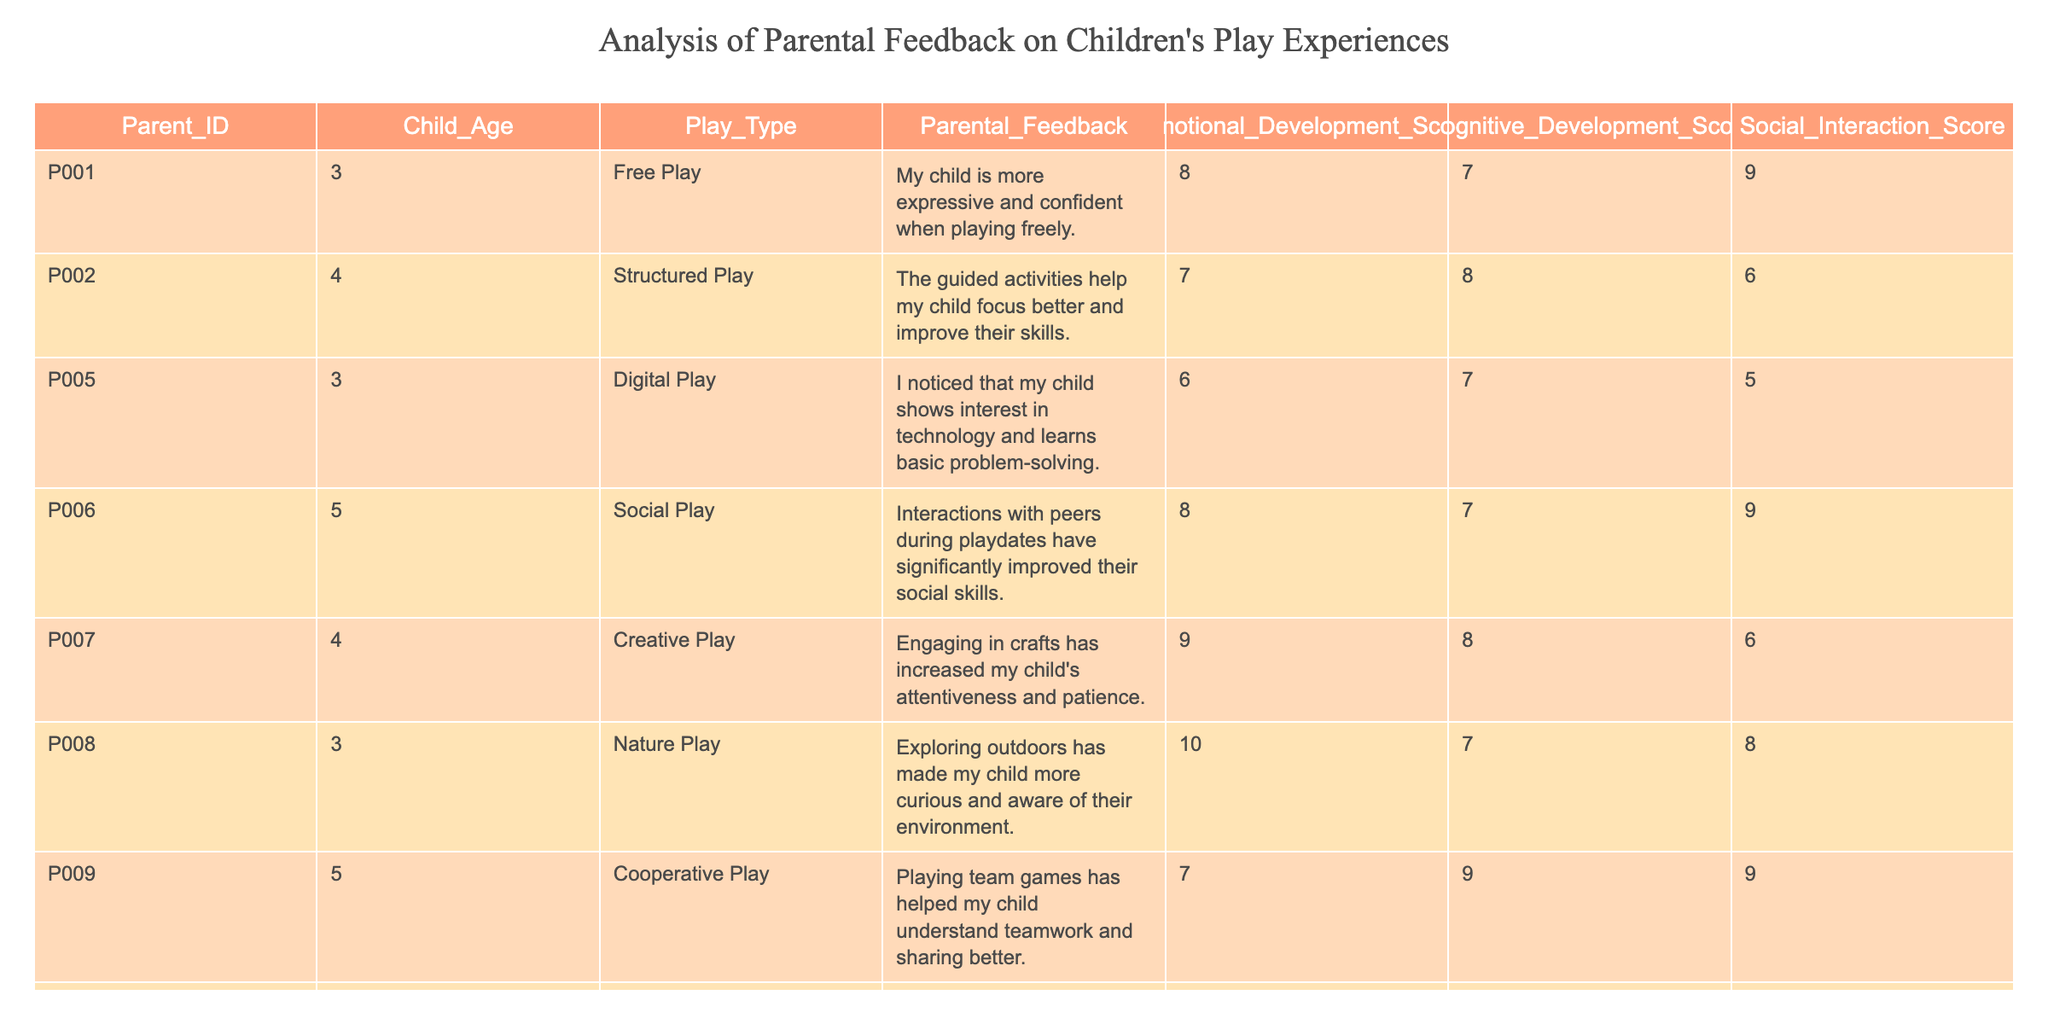What is the emotional development score for the child with parent ID P008? Looking at the table, we find the row with Parent_ID P008, which shows an Emotional Development Score of 10.
Answer: 10 What type of play has the highest cognitive development score? By examining the Cognitive Development Scores, we see that Creative Play (P007) has a score of 8, while the highest score is found with Cooperative Play (P009) at 9.
Answer: Cooperative Play Is it true that solitary play leads to a higher social interaction score than digital play? Looking at the Social Interaction Scores, Solitary Play (P010) has a score of 4, while Digital Play (P005) has a score of 5. Since 4 is not greater than 5, the statement is false.
Answer: No What is the average cognitive development score for children aged 3? The Cognitive Development Scores for children aged 3 are 9 (P001), 7 (P005), and 8 (P008). Summing these gives us 9 + 7 + 8 = 24. Since there are 3 children in this age group, we calculate the average as 24/3 = 8.
Answer: 8 Which type of play received the highest parental feedback in terms of emotional development? The highest Emotional Development Score is 10, which is associated with Nature Play (P008), indicating that parents observed significant positive emotional benefits from this type of play.
Answer: Nature Play How many children received a social interaction score of 9 or higher? The table indicates that children who received a score of 9 or higher in social interaction are P006, with 9, and P009, also with 9. Therefore, there are two children with scores in this range.
Answer: 2 What is the difference between the highest and lowest emotional development scores? The highest Emotional Development Score is 10 (P008) and the lowest is 6 (P010). The difference is 10 - 6 = 4.
Answer: 4 Which type of play has more consistent parental feedback, and how can we determine this? Looking at parental feedback statements, Free Play (P001) and Creative Play (P007) both demonstrate significant positive observations. However, Creative Play has a higher score in emotional development (9). Therefore, Creative Play can be seen as more consistently beneficial for emotional development.
Answer: Creative Play How does the emotional development score compare between digital play and cooperative play? The Emotional Development Score for Digital Play (P005) is 6, while for Cooperative Play (P009) it is 7. This shows that Cooperative Play received a higher score than Digital Play in this regard.
Answer: Cooperative Play has higher score 